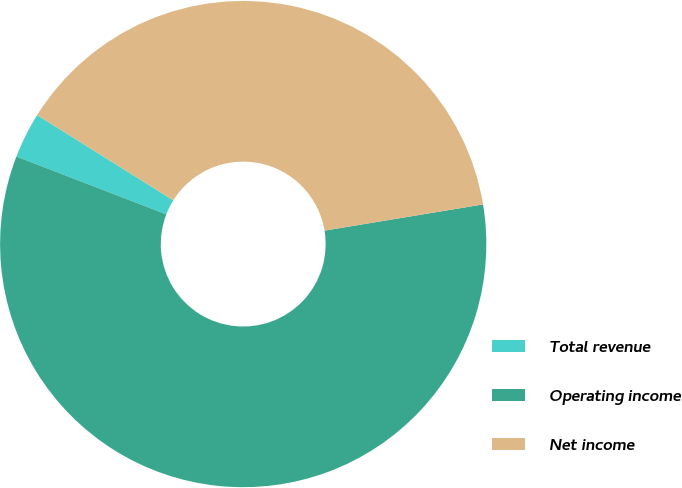Convert chart to OTSL. <chart><loc_0><loc_0><loc_500><loc_500><pie_chart><fcel>Total revenue<fcel>Operating income<fcel>Net income<nl><fcel>3.04%<fcel>58.47%<fcel>38.49%<nl></chart> 